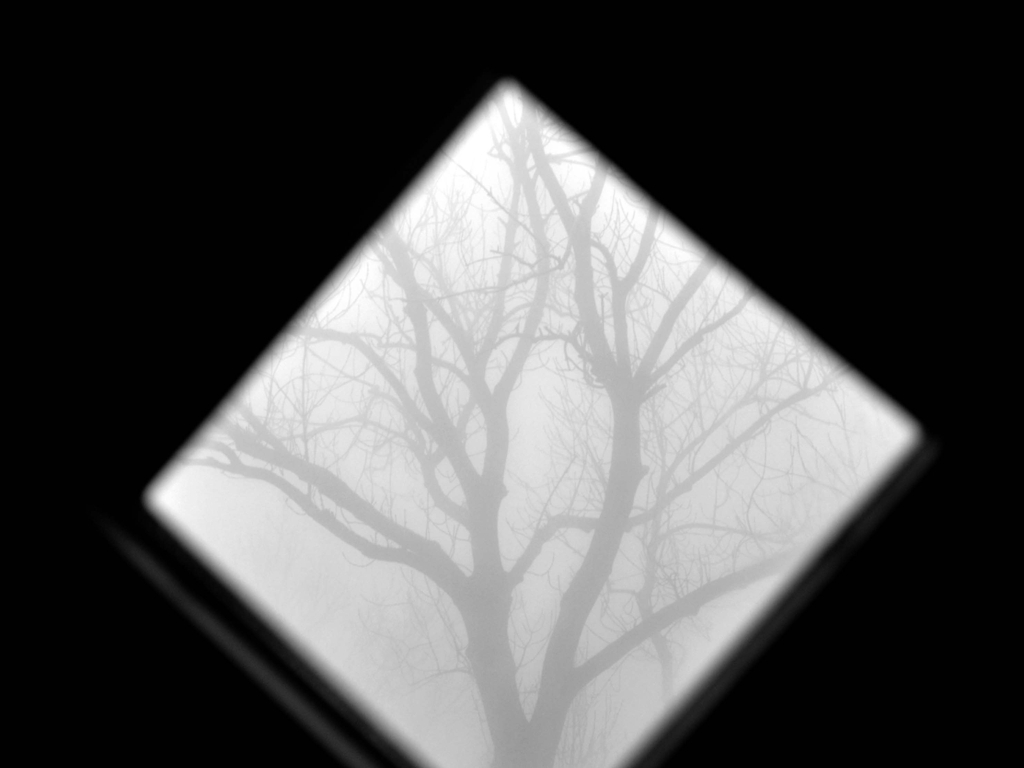What does the choice of black and white photography tell us about the mood or theme of the image? The use of black and white in this image strips away the distractions of color, emphasizing textures, shapes, and the interplay of light and shadow. This choice enhances the somber, introspective quality of the scene, focusing on the raw structural and emotional elements. It may suggest a timelessness, connecting the scene to universal themes of solitude, contemplation, and the complex nature of human emotions. 